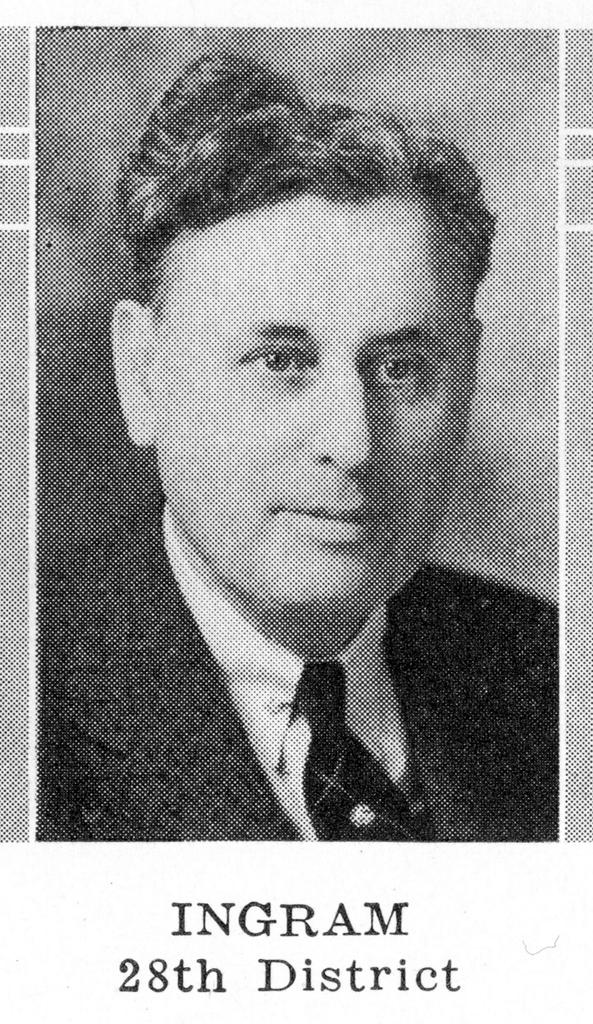What is the color scheme of the image? The image is black and white. Can you describe the main subject of the image? There is a person in the image. What type of steel is being used to create the leaf in the image? There is no steel or leaf present in the image; it is a black and white image featuring a person. 